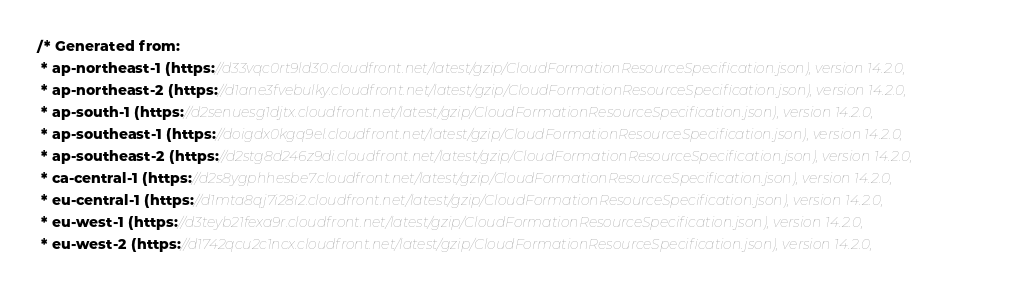Convert code to text. <code><loc_0><loc_0><loc_500><loc_500><_TypeScript_>/* Generated from: 
 * ap-northeast-1 (https://d33vqc0rt9ld30.cloudfront.net/latest/gzip/CloudFormationResourceSpecification.json), version 14.2.0,
 * ap-northeast-2 (https://d1ane3fvebulky.cloudfront.net/latest/gzip/CloudFormationResourceSpecification.json), version 14.2.0,
 * ap-south-1 (https://d2senuesg1djtx.cloudfront.net/latest/gzip/CloudFormationResourceSpecification.json), version 14.2.0,
 * ap-southeast-1 (https://doigdx0kgq9el.cloudfront.net/latest/gzip/CloudFormationResourceSpecification.json), version 14.2.0,
 * ap-southeast-2 (https://d2stg8d246z9di.cloudfront.net/latest/gzip/CloudFormationResourceSpecification.json), version 14.2.0,
 * ca-central-1 (https://d2s8ygphhesbe7.cloudfront.net/latest/gzip/CloudFormationResourceSpecification.json), version 14.2.0,
 * eu-central-1 (https://d1mta8qj7i28i2.cloudfront.net/latest/gzip/CloudFormationResourceSpecification.json), version 14.2.0,
 * eu-west-1 (https://d3teyb21fexa9r.cloudfront.net/latest/gzip/CloudFormationResourceSpecification.json), version 14.2.0,
 * eu-west-2 (https://d1742qcu2c1ncx.cloudfront.net/latest/gzip/CloudFormationResourceSpecification.json), version 14.2.0,</code> 